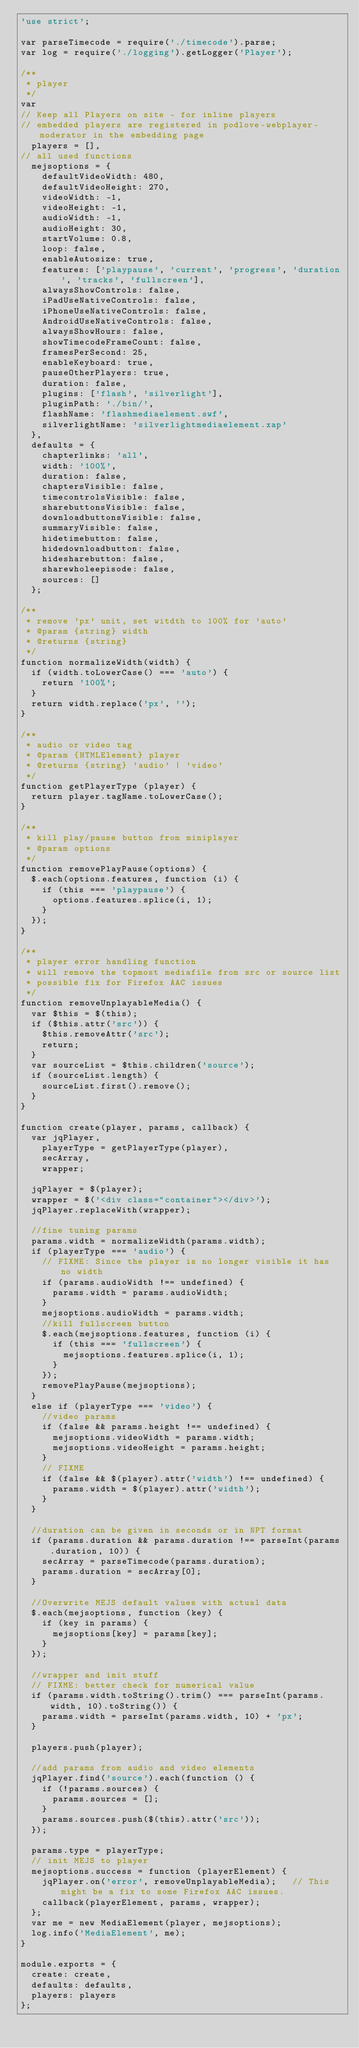Convert code to text. <code><loc_0><loc_0><loc_500><loc_500><_JavaScript_>'use strict';

var parseTimecode = require('./timecode').parse;
var log = require('./logging').getLogger('Player');

/**
 * player
 */
var
// Keep all Players on site - for inline players
// embedded players are registered in podlove-webplayer-moderator in the embedding page
  players = [],
// all used functions
  mejsoptions = {
    defaultVideoWidth: 480,
    defaultVideoHeight: 270,
    videoWidth: -1,
    videoHeight: -1,
    audioWidth: -1,
    audioHeight: 30,
    startVolume: 0.8,
    loop: false,
    enableAutosize: true,
    features: ['playpause', 'current', 'progress', 'duration', 'tracks', 'fullscreen'],
    alwaysShowControls: false,
    iPadUseNativeControls: false,
    iPhoneUseNativeControls: false,
    AndroidUseNativeControls: false,
    alwaysShowHours: false,
    showTimecodeFrameCount: false,
    framesPerSecond: 25,
    enableKeyboard: true,
    pauseOtherPlayers: true,
    duration: false,
    plugins: ['flash', 'silverlight'],
    pluginPath: './bin/',
    flashName: 'flashmediaelement.swf',
    silverlightName: 'silverlightmediaelement.xap'
  },
  defaults = {
    chapterlinks: 'all',
    width: '100%',
    duration: false,
    chaptersVisible: false,
    timecontrolsVisible: false,
    sharebuttonsVisible: false,
    downloadbuttonsVisible: false,
    summaryVisible: false,
    hidetimebutton: false,
    hidedownloadbutton: false,
    hidesharebutton: false,
    sharewholeepisode: false,
    sources: []
  };

/**
 * remove 'px' unit, set witdth to 100% for 'auto'
 * @param {string} width
 * @returns {string}
 */
function normalizeWidth(width) {
  if (width.toLowerCase() === 'auto') {
    return '100%';
  }
  return width.replace('px', '');
}

/**
 * audio or video tag
 * @param {HTMLElement} player
 * @returns {string} 'audio' | 'video'
 */
function getPlayerType (player) {
  return player.tagName.toLowerCase();
}

/**
 * kill play/pause button from miniplayer
 * @param options
 */
function removePlayPause(options) {
  $.each(options.features, function (i) {
    if (this === 'playpause') {
      options.features.splice(i, 1);
    }
  });
}

/**
 * player error handling function
 * will remove the topmost mediafile from src or source list
 * possible fix for Firefox AAC issues
 */
function removeUnplayableMedia() {
  var $this = $(this);
  if ($this.attr('src')) {
    $this.removeAttr('src');
    return;
  }
  var sourceList = $this.children('source');
  if (sourceList.length) {
    sourceList.first().remove();
  }
}

function create(player, params, callback) {
  var jqPlayer,
    playerType = getPlayerType(player),
    secArray,
    wrapper;

  jqPlayer = $(player);
  wrapper = $('<div class="container"></div>');
  jqPlayer.replaceWith(wrapper);

  //fine tuning params
  params.width = normalizeWidth(params.width);
  if (playerType === 'audio') {
    // FIXME: Since the player is no longer visible it has no width
    if (params.audioWidth !== undefined) {
      params.width = params.audioWidth;
    }
    mejsoptions.audioWidth = params.width;
    //kill fullscreen button
    $.each(mejsoptions.features, function (i) {
      if (this === 'fullscreen') {
        mejsoptions.features.splice(i, 1);
      }
    });
    removePlayPause(mejsoptions);
  }
  else if (playerType === 'video') {
    //video params
    if (false && params.height !== undefined) {
      mejsoptions.videoWidth = params.width;
      mejsoptions.videoHeight = params.height;
    }
    // FIXME
    if (false && $(player).attr('width') !== undefined) {
      params.width = $(player).attr('width');
    }
  }

  //duration can be given in seconds or in NPT format
  if (params.duration && params.duration !== parseInt(params.duration, 10)) {
    secArray = parseTimecode(params.duration);
    params.duration = secArray[0];
  }

  //Overwrite MEJS default values with actual data
  $.each(mejsoptions, function (key) {
    if (key in params) {
      mejsoptions[key] = params[key];
    }
  });

  //wrapper and init stuff
  // FIXME: better check for numerical value
  if (params.width.toString().trim() === parseInt(params.width, 10).toString()) {
    params.width = parseInt(params.width, 10) + 'px';
  }

  players.push(player);

  //add params from audio and video elements
  jqPlayer.find('source').each(function () {
    if (!params.sources) {
      params.sources = [];
    }
    params.sources.push($(this).attr('src'));
  });

  params.type = playerType;
  // init MEJS to player
  mejsoptions.success = function (playerElement) {
    jqPlayer.on('error', removeUnplayableMedia);   // This might be a fix to some Firefox AAC issues.
    callback(playerElement, params, wrapper);
  };
  var me = new MediaElement(player, mejsoptions);
  log.info('MediaElement', me);
}

module.exports = {
  create: create,
  defaults: defaults,
  players: players
};
</code> 